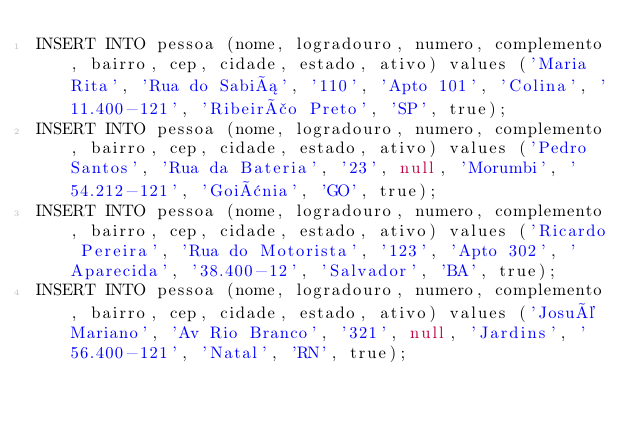<code> <loc_0><loc_0><loc_500><loc_500><_SQL_>INSERT INTO pessoa (nome, logradouro, numero, complemento, bairro, cep, cidade, estado, ativo) values ('Maria Rita', 'Rua do Sabiá', '110', 'Apto 101', 'Colina', '11.400-121', 'Ribeirão Preto', 'SP', true);
INSERT INTO pessoa (nome, logradouro, numero, complemento, bairro, cep, cidade, estado, ativo) values ('Pedro Santos', 'Rua da Bateria', '23', null, 'Morumbi', '54.212-121', 'Goiânia', 'GO', true);
INSERT INTO pessoa (nome, logradouro, numero, complemento, bairro, cep, cidade, estado, ativo) values ('Ricardo Pereira', 'Rua do Motorista', '123', 'Apto 302', 'Aparecida', '38.400-12', 'Salvador', 'BA', true);
INSERT INTO pessoa (nome, logradouro, numero, complemento, bairro, cep, cidade, estado, ativo) values ('Josué Mariano', 'Av Rio Branco', '321', null, 'Jardins', '56.400-121', 'Natal', 'RN', true);</code> 